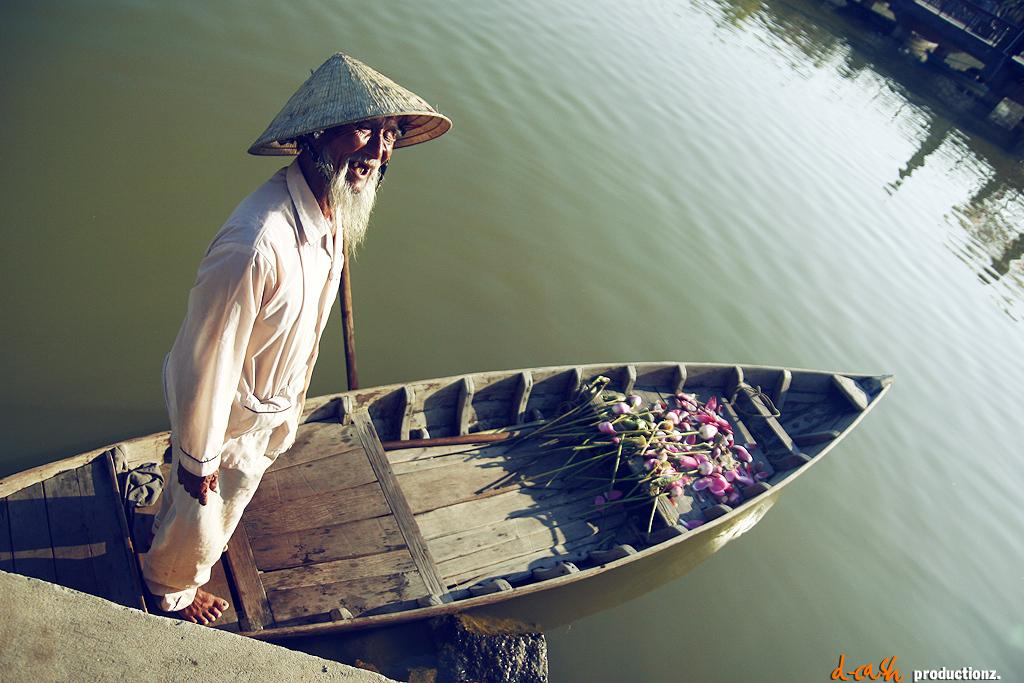What is the main subject of the image? The main subject of the image is a boat. Who or what is present in the boat? An old man is standing in the boat. What can be seen around the boat in the image? There is water visible in the image. What is the texture of the pet in the image? There is no pet present in the image. 